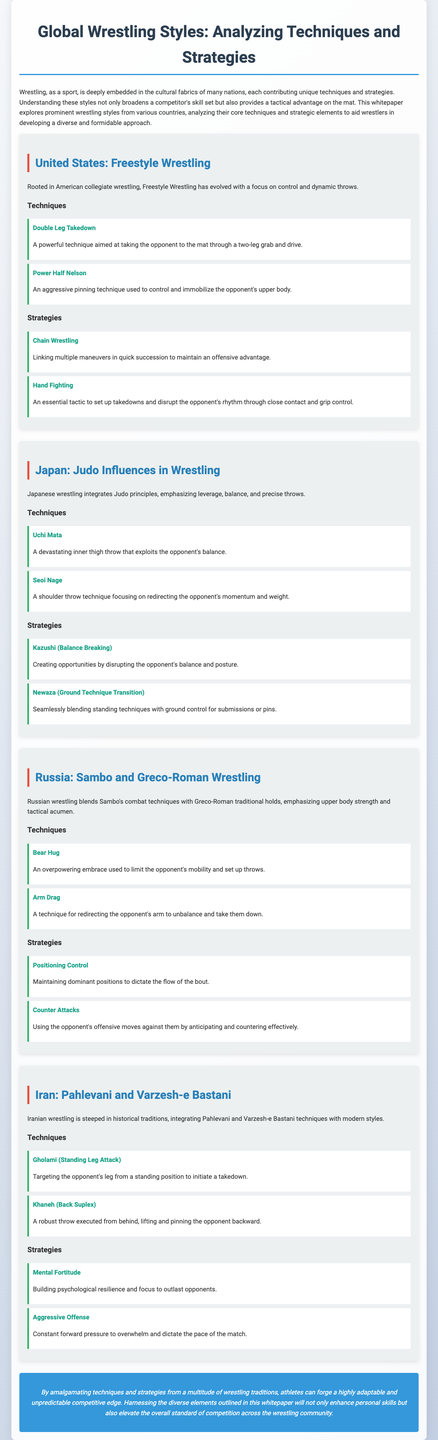what is the title of the whitepaper? The title provides the main subject of the document, which is about wrestling styles and techniques.
Answer: Global Wrestling Styles: Analyzing Techniques and Strategies which country is associated with Freestyle Wrestling? This refers to the specific section of the document discussing United States wrestling style.
Answer: United States what technique involves a powerful two-leg grab? This asks for a specific technique mentioned under the United States section.
Answer: Double Leg Takedown what strategy is described as linking multiple maneuvers? This strategy is found in the United States section and focuses on maintaining offensive advantage.
Answer: Chain Wrestling which country integrates Judo principles into wrestling? This relates to the section detailing Japanese influences in wrestling.
Answer: Japan what is the name of the back suplex technique used in Iranian wrestling? This question covers a specific technique listed in the Iran section.
Answer: Khaneh how many techniques are listed under Russia? This asks for a count of the specific wrestling techniques mentioned in the Russia section.
Answer: Two what does "Kazushi" refer to in Japanese wrestling? This refers to a strategic element in the Japan section focusing on balance.
Answer: Balance Breaking what is a common theme across all wrestling styles discussed? This question seeks to identify a shared element or objective in the document's analysis of wrestling styles.
Answer: Competitive edge 